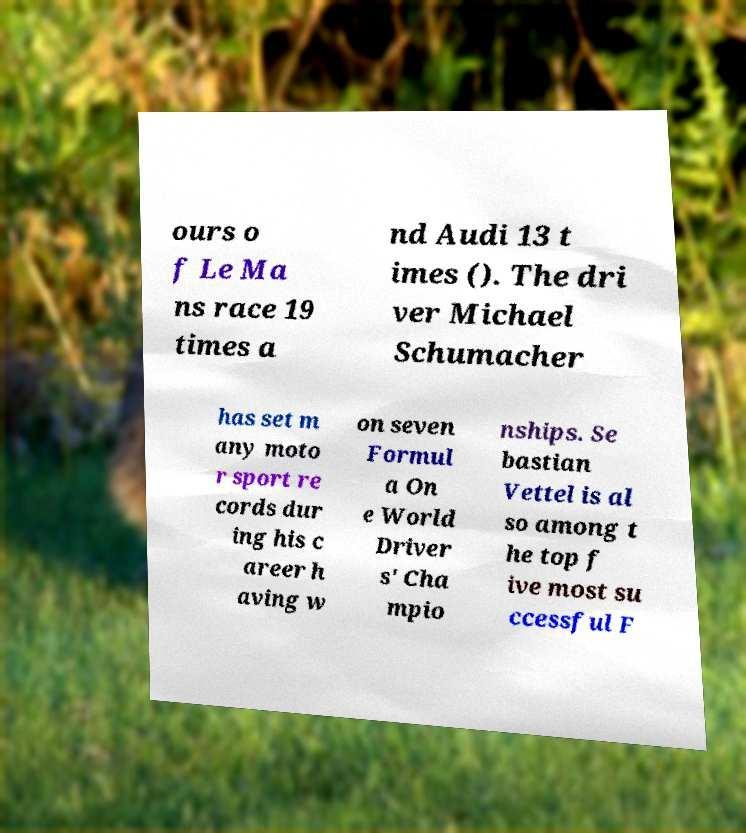There's text embedded in this image that I need extracted. Can you transcribe it verbatim? ours o f Le Ma ns race 19 times a nd Audi 13 t imes (). The dri ver Michael Schumacher has set m any moto r sport re cords dur ing his c areer h aving w on seven Formul a On e World Driver s' Cha mpio nships. Se bastian Vettel is al so among t he top f ive most su ccessful F 